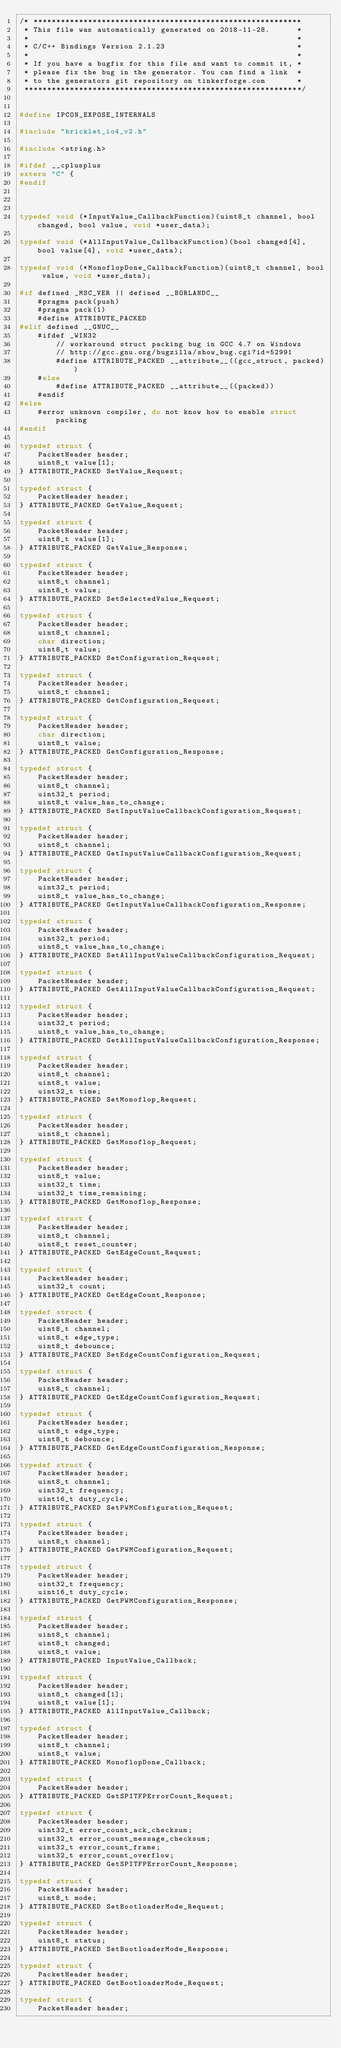Convert code to text. <code><loc_0><loc_0><loc_500><loc_500><_C_>/* ***********************************************************
 * This file was automatically generated on 2018-11-28.      *
 *                                                           *
 * C/C++ Bindings Version 2.1.23                             *
 *                                                           *
 * If you have a bugfix for this file and want to commit it, *
 * please fix the bug in the generator. You can find a link  *
 * to the generators git repository on tinkerforge.com       *
 *************************************************************/


#define IPCON_EXPOSE_INTERNALS

#include "bricklet_io4_v2.h"

#include <string.h>

#ifdef __cplusplus
extern "C" {
#endif



typedef void (*InputValue_CallbackFunction)(uint8_t channel, bool changed, bool value, void *user_data);

typedef void (*AllInputValue_CallbackFunction)(bool changed[4], bool value[4], void *user_data);

typedef void (*MonoflopDone_CallbackFunction)(uint8_t channel, bool value, void *user_data);

#if defined _MSC_VER || defined __BORLANDC__
	#pragma pack(push)
	#pragma pack(1)
	#define ATTRIBUTE_PACKED
#elif defined __GNUC__
	#ifdef _WIN32
		// workaround struct packing bug in GCC 4.7 on Windows
		// http://gcc.gnu.org/bugzilla/show_bug.cgi?id=52991
		#define ATTRIBUTE_PACKED __attribute__((gcc_struct, packed))
	#else
		#define ATTRIBUTE_PACKED __attribute__((packed))
	#endif
#else
	#error unknown compiler, do not know how to enable struct packing
#endif

typedef struct {
	PacketHeader header;
	uint8_t value[1];
} ATTRIBUTE_PACKED SetValue_Request;

typedef struct {
	PacketHeader header;
} ATTRIBUTE_PACKED GetValue_Request;

typedef struct {
	PacketHeader header;
	uint8_t value[1];
} ATTRIBUTE_PACKED GetValue_Response;

typedef struct {
	PacketHeader header;
	uint8_t channel;
	uint8_t value;
} ATTRIBUTE_PACKED SetSelectedValue_Request;

typedef struct {
	PacketHeader header;
	uint8_t channel;
	char direction;
	uint8_t value;
} ATTRIBUTE_PACKED SetConfiguration_Request;

typedef struct {
	PacketHeader header;
	uint8_t channel;
} ATTRIBUTE_PACKED GetConfiguration_Request;

typedef struct {
	PacketHeader header;
	char direction;
	uint8_t value;
} ATTRIBUTE_PACKED GetConfiguration_Response;

typedef struct {
	PacketHeader header;
	uint8_t channel;
	uint32_t period;
	uint8_t value_has_to_change;
} ATTRIBUTE_PACKED SetInputValueCallbackConfiguration_Request;

typedef struct {
	PacketHeader header;
	uint8_t channel;
} ATTRIBUTE_PACKED GetInputValueCallbackConfiguration_Request;

typedef struct {
	PacketHeader header;
	uint32_t period;
	uint8_t value_has_to_change;
} ATTRIBUTE_PACKED GetInputValueCallbackConfiguration_Response;

typedef struct {
	PacketHeader header;
	uint32_t period;
	uint8_t value_has_to_change;
} ATTRIBUTE_PACKED SetAllInputValueCallbackConfiguration_Request;

typedef struct {
	PacketHeader header;
} ATTRIBUTE_PACKED GetAllInputValueCallbackConfiguration_Request;

typedef struct {
	PacketHeader header;
	uint32_t period;
	uint8_t value_has_to_change;
} ATTRIBUTE_PACKED GetAllInputValueCallbackConfiguration_Response;

typedef struct {
	PacketHeader header;
	uint8_t channel;
	uint8_t value;
	uint32_t time;
} ATTRIBUTE_PACKED SetMonoflop_Request;

typedef struct {
	PacketHeader header;
	uint8_t channel;
} ATTRIBUTE_PACKED GetMonoflop_Request;

typedef struct {
	PacketHeader header;
	uint8_t value;
	uint32_t time;
	uint32_t time_remaining;
} ATTRIBUTE_PACKED GetMonoflop_Response;

typedef struct {
	PacketHeader header;
	uint8_t channel;
	uint8_t reset_counter;
} ATTRIBUTE_PACKED GetEdgeCount_Request;

typedef struct {
	PacketHeader header;
	uint32_t count;
} ATTRIBUTE_PACKED GetEdgeCount_Response;

typedef struct {
	PacketHeader header;
	uint8_t channel;
	uint8_t edge_type;
	uint8_t debounce;
} ATTRIBUTE_PACKED SetEdgeCountConfiguration_Request;

typedef struct {
	PacketHeader header;
	uint8_t channel;
} ATTRIBUTE_PACKED GetEdgeCountConfiguration_Request;

typedef struct {
	PacketHeader header;
	uint8_t edge_type;
	uint8_t debounce;
} ATTRIBUTE_PACKED GetEdgeCountConfiguration_Response;

typedef struct {
	PacketHeader header;
	uint8_t channel;
	uint32_t frequency;
	uint16_t duty_cycle;
} ATTRIBUTE_PACKED SetPWMConfiguration_Request;

typedef struct {
	PacketHeader header;
	uint8_t channel;
} ATTRIBUTE_PACKED GetPWMConfiguration_Request;

typedef struct {
	PacketHeader header;
	uint32_t frequency;
	uint16_t duty_cycle;
} ATTRIBUTE_PACKED GetPWMConfiguration_Response;

typedef struct {
	PacketHeader header;
	uint8_t channel;
	uint8_t changed;
	uint8_t value;
} ATTRIBUTE_PACKED InputValue_Callback;

typedef struct {
	PacketHeader header;
	uint8_t changed[1];
	uint8_t value[1];
} ATTRIBUTE_PACKED AllInputValue_Callback;

typedef struct {
	PacketHeader header;
	uint8_t channel;
	uint8_t value;
} ATTRIBUTE_PACKED MonoflopDone_Callback;

typedef struct {
	PacketHeader header;
} ATTRIBUTE_PACKED GetSPITFPErrorCount_Request;

typedef struct {
	PacketHeader header;
	uint32_t error_count_ack_checksum;
	uint32_t error_count_message_checksum;
	uint32_t error_count_frame;
	uint32_t error_count_overflow;
} ATTRIBUTE_PACKED GetSPITFPErrorCount_Response;

typedef struct {
	PacketHeader header;
	uint8_t mode;
} ATTRIBUTE_PACKED SetBootloaderMode_Request;

typedef struct {
	PacketHeader header;
	uint8_t status;
} ATTRIBUTE_PACKED SetBootloaderMode_Response;

typedef struct {
	PacketHeader header;
} ATTRIBUTE_PACKED GetBootloaderMode_Request;

typedef struct {
	PacketHeader header;</code> 